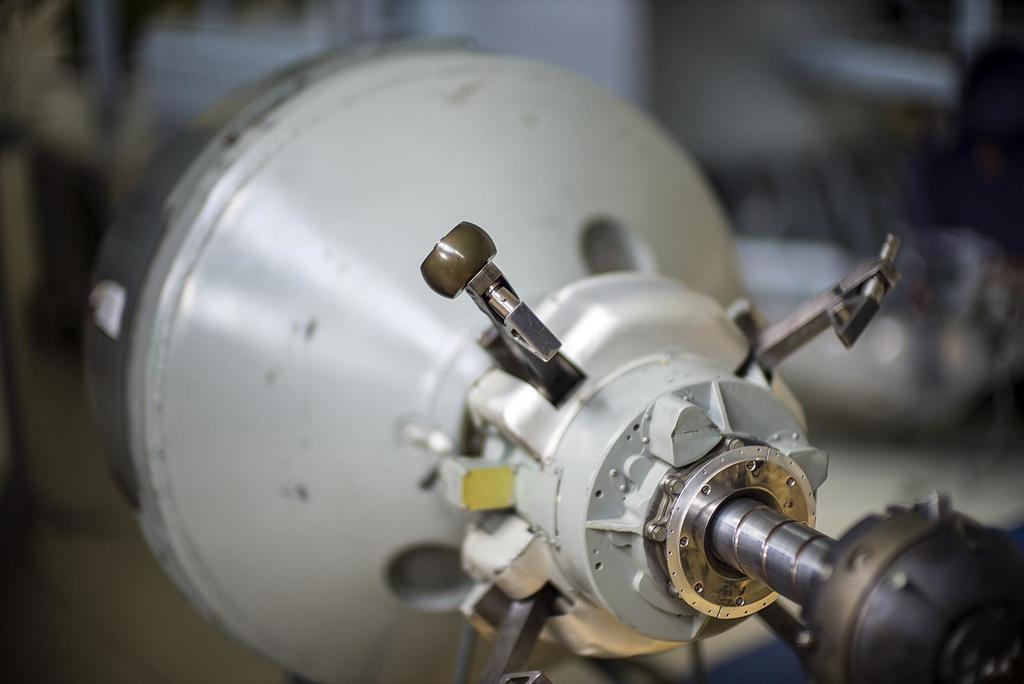What is the main subject of the image? The main subject of the image is an electric rotor. Can you describe the background of the image? The background of the image appears blurry. In which direction does the north pole face in the image? There is no reference to a north pole or any directional information in the image. 